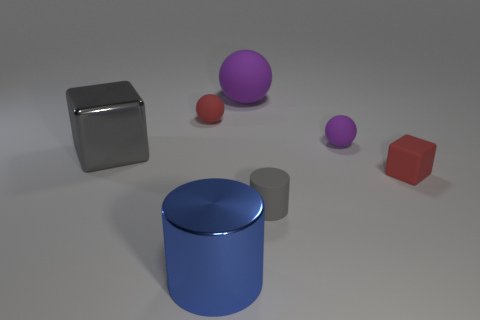What material is the gray object that is to the right of the gray thing to the left of the large blue object?
Give a very brief answer. Rubber. What is the size of the other purple thing that is the same shape as the small purple matte object?
Give a very brief answer. Large. Do the shiny block and the small cylinder have the same color?
Provide a short and direct response. Yes. The rubber object that is right of the gray matte thing and behind the gray metal block is what color?
Offer a terse response. Purple. Does the gray object that is in front of the gray shiny thing have the same size as the large rubber ball?
Offer a very short reply. No. Is the gray block made of the same material as the tiny sphere to the left of the blue metallic object?
Offer a very short reply. No. How many purple objects are either large rubber things or big rubber cubes?
Ensure brevity in your answer.  1. Are any small red metal balls visible?
Your response must be concise. No. There is a ball behind the matte ball to the left of the large blue metallic thing; is there a small red matte ball that is right of it?
Offer a very short reply. No. There is a tiny purple object; does it have the same shape as the metallic object behind the tiny rubber cylinder?
Your response must be concise. No. 